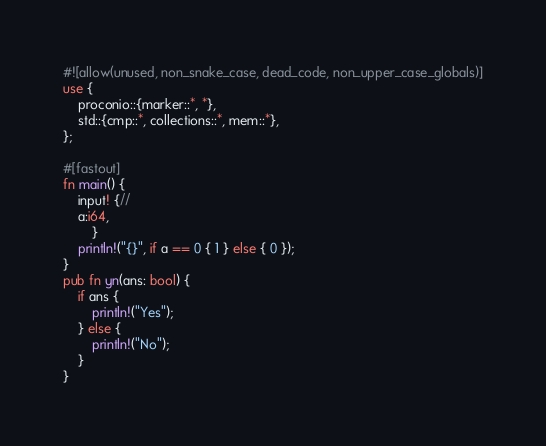<code> <loc_0><loc_0><loc_500><loc_500><_Rust_>#![allow(unused, non_snake_case, dead_code, non_upper_case_globals)]
use {
    proconio::{marker::*, *},
    std::{cmp::*, collections::*, mem::*},
};

#[fastout]
fn main() {
    input! {//
    a:i64,
        }
    println!("{}", if a == 0 { 1 } else { 0 });
}
pub fn yn(ans: bool) {
    if ans {
        println!("Yes");
    } else {
        println!("No");
    }
}
</code> 